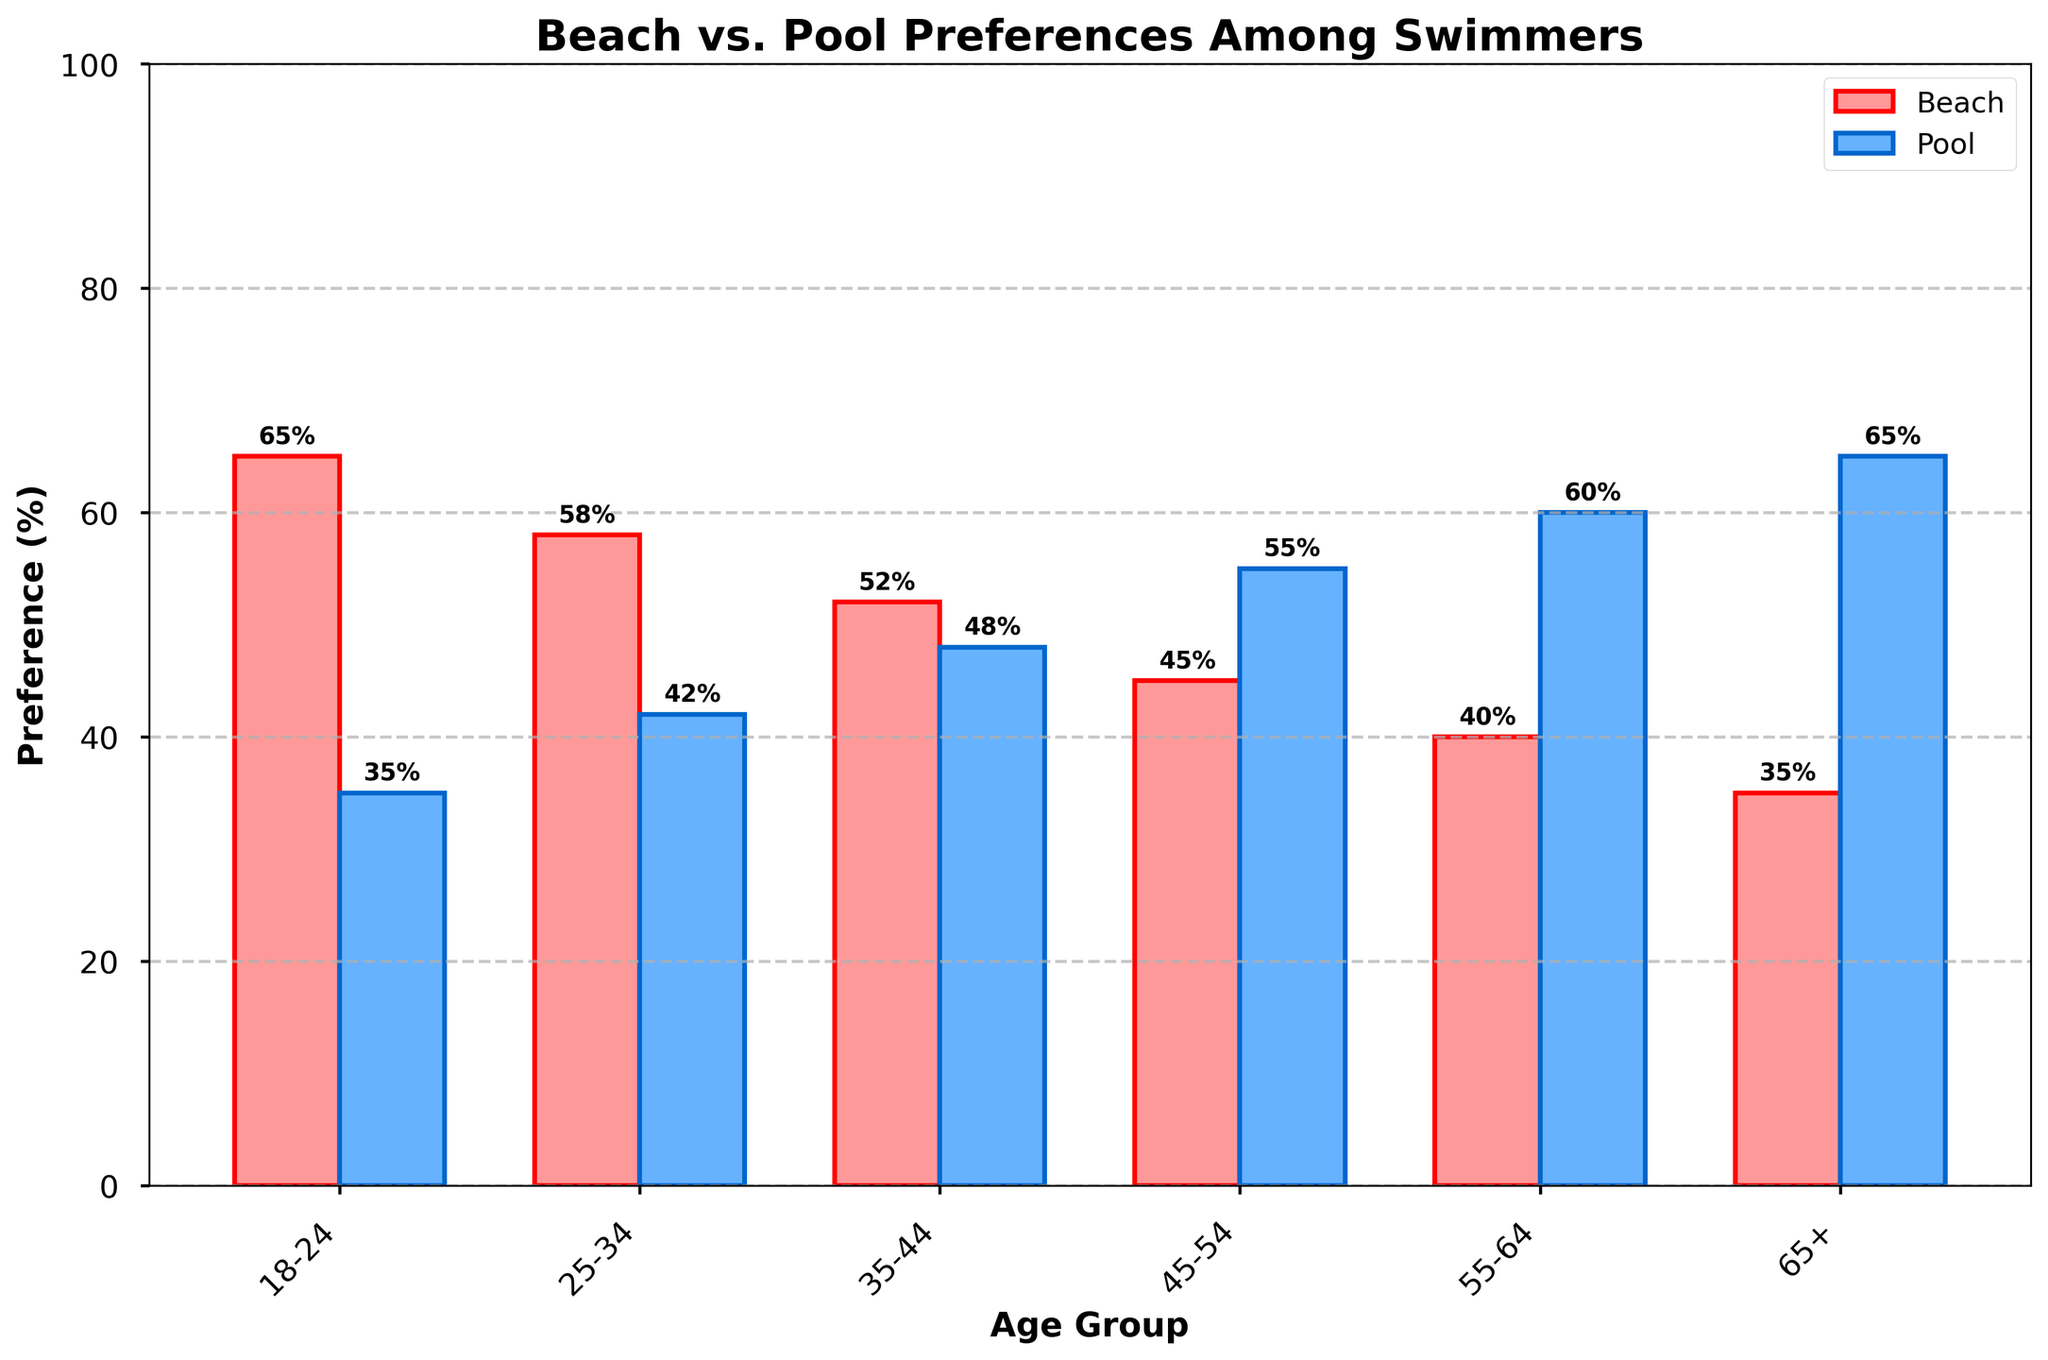What age group prefers the beach the most? The age group with the highest "Beach Preference (%)" value has the greatest preference for the beach. According to the figure, the 18-24 age group has the highest beach preference at 65%.
Answer: The 18-24 age group What is the difference in beach preference between the 25-34 age group and the 45-54 age group? Subtract the "Beach Preference (%)" value of the 45-54 age group from that of the 25-34 age group. The values are 58% for 25-34 and 45% for 45-54. Therefore, 58% - 45% = 13%.
Answer: 13% Which age group shows a higher preference for pools than the 35-44 age group? Compare the "Pool Preference (%)" values of the age groups with that of the 35-44 age group (which is 48%). The 45-54, 55-64, and 65+ age groups have values of 55%, 60%, and 65% respectively, which are all higher than 48%.
Answer: 45-54, 55-64, and 65+ What is the total preference for the pool across all age groups? Add up all the "Pool Preference (%)" values: 35% (18-24) + 42% (25-34) + 48% (35-44) + 55% (45-54) + 60% (55-64) + 65% (65+). The sum is 305%.
Answer: 305% How many age groups have a beach preference that is more than 50%? Count the age groups with "Beach Preference (%)" values greater than 50%. These are 18-24 (65%), 25-34 (58%), and 35-44 (52%). There are 3 such groups.
Answer: 3 What is the trend in beach preference as age increases? Look at the "Beach Preference (%)" values for each consecutive age group starting from 18-24 up to 65+. The values are 65%, 58%, 52%, 45%, 40%, and 35%, showing a decreasing trend.
Answer: Decreasing trend Is there any age group where the preference for the beach and pool is equal? Check if there is an age group where "Beach Preference (%)" equals "Pool Preference (%)". There is no such age group as per the figure.
Answer: No Which age group has the largest difference between their beach and pool preferences? Calculate the absolute difference between "Beach Preference (%)" and "Pool Preference (%)" for each group and compare them. The differences are 30% (18-24), 16% (25-34), 4% (35-44), 10% (45-54), 20% (55-64), and 30% (65+). The largest differences are 30% for both 18-24 and 65+ age groups.
Answer: 18-24 and 65+ What age group prefers the pool the most? The age group with the highest "Pool Preference (%)" value has the greatest preference for the pool. According to the figure, the 65+ age group has the highest pool preference at 65%.
Answer: 65+ 